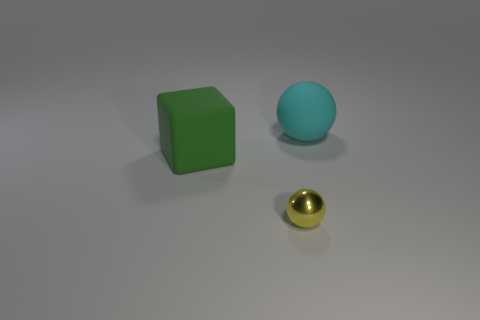Add 2 big gray cubes. How many objects exist? 5 Subtract all cubes. How many objects are left? 2 Add 2 green blocks. How many green blocks are left? 3 Add 3 large green things. How many large green things exist? 4 Subtract 1 yellow spheres. How many objects are left? 2 Subtract all large matte blocks. Subtract all yellow matte blocks. How many objects are left? 2 